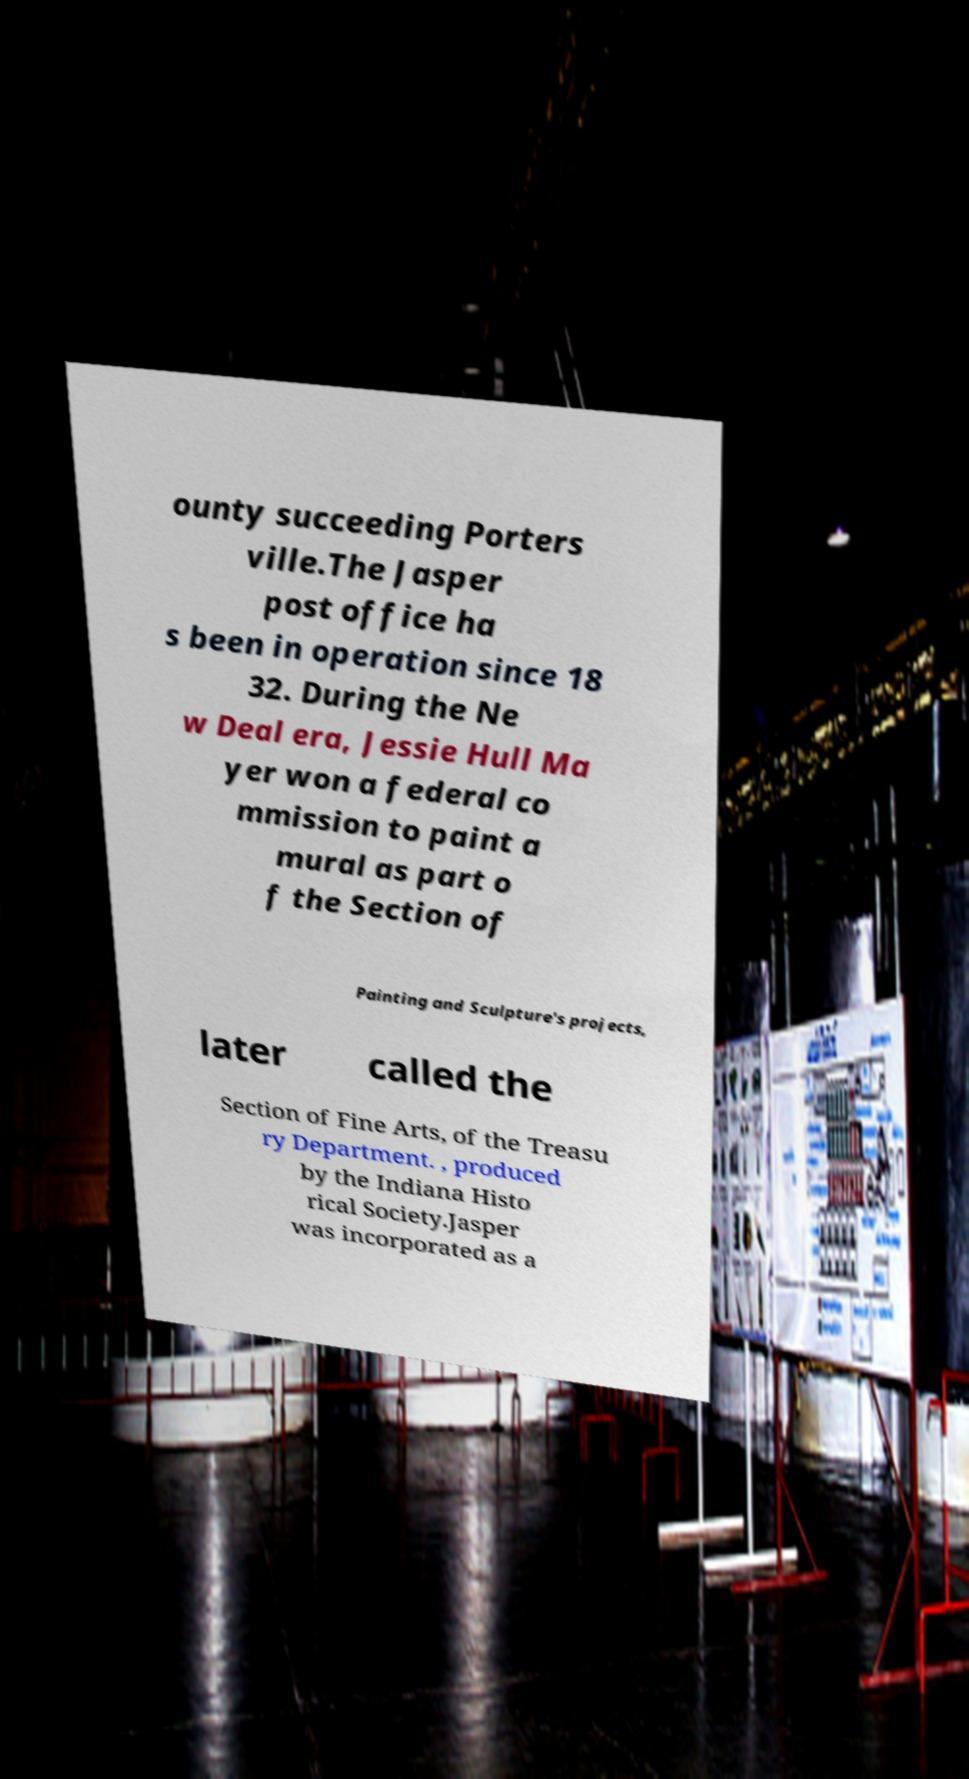Could you assist in decoding the text presented in this image and type it out clearly? ounty succeeding Porters ville.The Jasper post office ha s been in operation since 18 32. During the Ne w Deal era, Jessie Hull Ma yer won a federal co mmission to paint a mural as part o f the Section of Painting and Sculpture′s projects, later called the Section of Fine Arts, of the Treasu ry Department. , produced by the Indiana Histo rical Society.Jasper was incorporated as a 